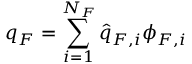Convert formula to latex. <formula><loc_0><loc_0><loc_500><loc_500>q _ { F } = \sum _ { i = 1 } ^ { N _ { F } } \widehat { q } _ { F , i } \phi _ { F , i }</formula> 